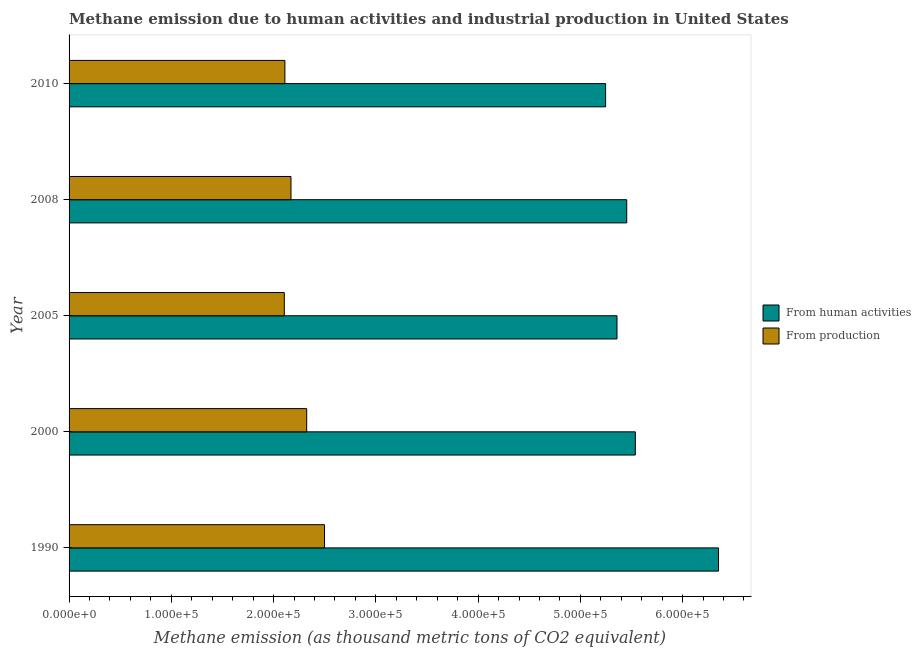How many groups of bars are there?
Offer a terse response. 5. Are the number of bars per tick equal to the number of legend labels?
Provide a succinct answer. Yes. Are the number of bars on each tick of the Y-axis equal?
Provide a succinct answer. Yes. How many bars are there on the 3rd tick from the top?
Make the answer very short. 2. What is the label of the 2nd group of bars from the top?
Keep it short and to the point. 2008. In how many cases, is the number of bars for a given year not equal to the number of legend labels?
Ensure brevity in your answer.  0. What is the amount of emissions generated from industries in 2008?
Your answer should be compact. 2.17e+05. Across all years, what is the maximum amount of emissions from human activities?
Offer a very short reply. 6.35e+05. Across all years, what is the minimum amount of emissions generated from industries?
Provide a succinct answer. 2.10e+05. In which year was the amount of emissions generated from industries maximum?
Provide a succinct answer. 1990. In which year was the amount of emissions from human activities minimum?
Give a very brief answer. 2010. What is the total amount of emissions generated from industries in the graph?
Provide a succinct answer. 1.12e+06. What is the difference between the amount of emissions generated from industries in 2000 and that in 2005?
Keep it short and to the point. 2.19e+04. What is the difference between the amount of emissions generated from industries in 2005 and the amount of emissions from human activities in 2008?
Your response must be concise. -3.35e+05. What is the average amount of emissions generated from industries per year?
Offer a terse response. 2.24e+05. In the year 2000, what is the difference between the amount of emissions generated from industries and amount of emissions from human activities?
Ensure brevity in your answer.  -3.21e+05. In how many years, is the amount of emissions generated from industries greater than 340000 thousand metric tons?
Provide a succinct answer. 0. What is the ratio of the amount of emissions generated from industries in 1990 to that in 2005?
Ensure brevity in your answer.  1.19. Is the amount of emissions generated from industries in 1990 less than that in 2000?
Your answer should be compact. No. What is the difference between the highest and the second highest amount of emissions from human activities?
Offer a very short reply. 8.14e+04. What is the difference between the highest and the lowest amount of emissions generated from industries?
Offer a terse response. 3.93e+04. Is the sum of the amount of emissions generated from industries in 1990 and 2005 greater than the maximum amount of emissions from human activities across all years?
Your answer should be compact. No. What does the 1st bar from the top in 2000 represents?
Offer a terse response. From production. What does the 1st bar from the bottom in 2008 represents?
Your answer should be very brief. From human activities. How many bars are there?
Ensure brevity in your answer.  10. How many years are there in the graph?
Provide a succinct answer. 5. What is the difference between two consecutive major ticks on the X-axis?
Offer a very short reply. 1.00e+05. Are the values on the major ticks of X-axis written in scientific E-notation?
Your response must be concise. Yes. Does the graph contain any zero values?
Provide a short and direct response. No. What is the title of the graph?
Make the answer very short. Methane emission due to human activities and industrial production in United States. Does "Savings" appear as one of the legend labels in the graph?
Your answer should be very brief. No. What is the label or title of the X-axis?
Make the answer very short. Methane emission (as thousand metric tons of CO2 equivalent). What is the label or title of the Y-axis?
Offer a terse response. Year. What is the Methane emission (as thousand metric tons of CO2 equivalent) in From human activities in 1990?
Your response must be concise. 6.35e+05. What is the Methane emission (as thousand metric tons of CO2 equivalent) of From production in 1990?
Offer a very short reply. 2.50e+05. What is the Methane emission (as thousand metric tons of CO2 equivalent) in From human activities in 2000?
Make the answer very short. 5.54e+05. What is the Methane emission (as thousand metric tons of CO2 equivalent) in From production in 2000?
Ensure brevity in your answer.  2.32e+05. What is the Methane emission (as thousand metric tons of CO2 equivalent) in From human activities in 2005?
Make the answer very short. 5.36e+05. What is the Methane emission (as thousand metric tons of CO2 equivalent) of From production in 2005?
Your answer should be very brief. 2.10e+05. What is the Methane emission (as thousand metric tons of CO2 equivalent) of From human activities in 2008?
Your answer should be very brief. 5.45e+05. What is the Methane emission (as thousand metric tons of CO2 equivalent) in From production in 2008?
Offer a terse response. 2.17e+05. What is the Methane emission (as thousand metric tons of CO2 equivalent) in From human activities in 2010?
Offer a terse response. 5.25e+05. What is the Methane emission (as thousand metric tons of CO2 equivalent) in From production in 2010?
Make the answer very short. 2.11e+05. Across all years, what is the maximum Methane emission (as thousand metric tons of CO2 equivalent) in From human activities?
Offer a terse response. 6.35e+05. Across all years, what is the maximum Methane emission (as thousand metric tons of CO2 equivalent) in From production?
Keep it short and to the point. 2.50e+05. Across all years, what is the minimum Methane emission (as thousand metric tons of CO2 equivalent) of From human activities?
Provide a succinct answer. 5.25e+05. Across all years, what is the minimum Methane emission (as thousand metric tons of CO2 equivalent) of From production?
Your answer should be compact. 2.10e+05. What is the total Methane emission (as thousand metric tons of CO2 equivalent) of From human activities in the graph?
Make the answer very short. 2.79e+06. What is the total Methane emission (as thousand metric tons of CO2 equivalent) of From production in the graph?
Provide a succinct answer. 1.12e+06. What is the difference between the Methane emission (as thousand metric tons of CO2 equivalent) in From human activities in 1990 and that in 2000?
Offer a terse response. 8.14e+04. What is the difference between the Methane emission (as thousand metric tons of CO2 equivalent) of From production in 1990 and that in 2000?
Ensure brevity in your answer.  1.74e+04. What is the difference between the Methane emission (as thousand metric tons of CO2 equivalent) in From human activities in 1990 and that in 2005?
Offer a terse response. 9.93e+04. What is the difference between the Methane emission (as thousand metric tons of CO2 equivalent) of From production in 1990 and that in 2005?
Your answer should be compact. 3.93e+04. What is the difference between the Methane emission (as thousand metric tons of CO2 equivalent) of From human activities in 1990 and that in 2008?
Offer a terse response. 8.98e+04. What is the difference between the Methane emission (as thousand metric tons of CO2 equivalent) of From production in 1990 and that in 2008?
Your response must be concise. 3.28e+04. What is the difference between the Methane emission (as thousand metric tons of CO2 equivalent) in From human activities in 1990 and that in 2010?
Offer a terse response. 1.10e+05. What is the difference between the Methane emission (as thousand metric tons of CO2 equivalent) of From production in 1990 and that in 2010?
Your answer should be compact. 3.87e+04. What is the difference between the Methane emission (as thousand metric tons of CO2 equivalent) in From human activities in 2000 and that in 2005?
Keep it short and to the point. 1.79e+04. What is the difference between the Methane emission (as thousand metric tons of CO2 equivalent) of From production in 2000 and that in 2005?
Ensure brevity in your answer.  2.19e+04. What is the difference between the Methane emission (as thousand metric tons of CO2 equivalent) of From human activities in 2000 and that in 2008?
Keep it short and to the point. 8414.7. What is the difference between the Methane emission (as thousand metric tons of CO2 equivalent) in From production in 2000 and that in 2008?
Offer a very short reply. 1.54e+04. What is the difference between the Methane emission (as thousand metric tons of CO2 equivalent) in From human activities in 2000 and that in 2010?
Your answer should be very brief. 2.91e+04. What is the difference between the Methane emission (as thousand metric tons of CO2 equivalent) in From production in 2000 and that in 2010?
Offer a very short reply. 2.13e+04. What is the difference between the Methane emission (as thousand metric tons of CO2 equivalent) in From human activities in 2005 and that in 2008?
Provide a short and direct response. -9510.3. What is the difference between the Methane emission (as thousand metric tons of CO2 equivalent) in From production in 2005 and that in 2008?
Provide a succinct answer. -6538.2. What is the difference between the Methane emission (as thousand metric tons of CO2 equivalent) in From human activities in 2005 and that in 2010?
Your answer should be compact. 1.11e+04. What is the difference between the Methane emission (as thousand metric tons of CO2 equivalent) of From production in 2005 and that in 2010?
Make the answer very short. -598.4. What is the difference between the Methane emission (as thousand metric tons of CO2 equivalent) in From human activities in 2008 and that in 2010?
Keep it short and to the point. 2.06e+04. What is the difference between the Methane emission (as thousand metric tons of CO2 equivalent) in From production in 2008 and that in 2010?
Provide a succinct answer. 5939.8. What is the difference between the Methane emission (as thousand metric tons of CO2 equivalent) in From human activities in 1990 and the Methane emission (as thousand metric tons of CO2 equivalent) in From production in 2000?
Keep it short and to the point. 4.03e+05. What is the difference between the Methane emission (as thousand metric tons of CO2 equivalent) in From human activities in 1990 and the Methane emission (as thousand metric tons of CO2 equivalent) in From production in 2005?
Your response must be concise. 4.25e+05. What is the difference between the Methane emission (as thousand metric tons of CO2 equivalent) in From human activities in 1990 and the Methane emission (as thousand metric tons of CO2 equivalent) in From production in 2008?
Provide a succinct answer. 4.18e+05. What is the difference between the Methane emission (as thousand metric tons of CO2 equivalent) of From human activities in 1990 and the Methane emission (as thousand metric tons of CO2 equivalent) of From production in 2010?
Your answer should be compact. 4.24e+05. What is the difference between the Methane emission (as thousand metric tons of CO2 equivalent) in From human activities in 2000 and the Methane emission (as thousand metric tons of CO2 equivalent) in From production in 2005?
Your answer should be compact. 3.43e+05. What is the difference between the Methane emission (as thousand metric tons of CO2 equivalent) of From human activities in 2000 and the Methane emission (as thousand metric tons of CO2 equivalent) of From production in 2008?
Your response must be concise. 3.37e+05. What is the difference between the Methane emission (as thousand metric tons of CO2 equivalent) of From human activities in 2000 and the Methane emission (as thousand metric tons of CO2 equivalent) of From production in 2010?
Keep it short and to the point. 3.43e+05. What is the difference between the Methane emission (as thousand metric tons of CO2 equivalent) in From human activities in 2005 and the Methane emission (as thousand metric tons of CO2 equivalent) in From production in 2008?
Offer a very short reply. 3.19e+05. What is the difference between the Methane emission (as thousand metric tons of CO2 equivalent) in From human activities in 2005 and the Methane emission (as thousand metric tons of CO2 equivalent) in From production in 2010?
Your answer should be very brief. 3.25e+05. What is the difference between the Methane emission (as thousand metric tons of CO2 equivalent) of From human activities in 2008 and the Methane emission (as thousand metric tons of CO2 equivalent) of From production in 2010?
Make the answer very short. 3.34e+05. What is the average Methane emission (as thousand metric tons of CO2 equivalent) in From human activities per year?
Ensure brevity in your answer.  5.59e+05. What is the average Methane emission (as thousand metric tons of CO2 equivalent) in From production per year?
Keep it short and to the point. 2.24e+05. In the year 1990, what is the difference between the Methane emission (as thousand metric tons of CO2 equivalent) in From human activities and Methane emission (as thousand metric tons of CO2 equivalent) in From production?
Your answer should be very brief. 3.85e+05. In the year 2000, what is the difference between the Methane emission (as thousand metric tons of CO2 equivalent) in From human activities and Methane emission (as thousand metric tons of CO2 equivalent) in From production?
Ensure brevity in your answer.  3.21e+05. In the year 2005, what is the difference between the Methane emission (as thousand metric tons of CO2 equivalent) of From human activities and Methane emission (as thousand metric tons of CO2 equivalent) of From production?
Give a very brief answer. 3.25e+05. In the year 2008, what is the difference between the Methane emission (as thousand metric tons of CO2 equivalent) of From human activities and Methane emission (as thousand metric tons of CO2 equivalent) of From production?
Give a very brief answer. 3.28e+05. In the year 2010, what is the difference between the Methane emission (as thousand metric tons of CO2 equivalent) in From human activities and Methane emission (as thousand metric tons of CO2 equivalent) in From production?
Give a very brief answer. 3.14e+05. What is the ratio of the Methane emission (as thousand metric tons of CO2 equivalent) in From human activities in 1990 to that in 2000?
Offer a terse response. 1.15. What is the ratio of the Methane emission (as thousand metric tons of CO2 equivalent) in From production in 1990 to that in 2000?
Keep it short and to the point. 1.07. What is the ratio of the Methane emission (as thousand metric tons of CO2 equivalent) of From human activities in 1990 to that in 2005?
Your response must be concise. 1.19. What is the ratio of the Methane emission (as thousand metric tons of CO2 equivalent) of From production in 1990 to that in 2005?
Make the answer very short. 1.19. What is the ratio of the Methane emission (as thousand metric tons of CO2 equivalent) in From human activities in 1990 to that in 2008?
Your answer should be very brief. 1.16. What is the ratio of the Methane emission (as thousand metric tons of CO2 equivalent) of From production in 1990 to that in 2008?
Provide a short and direct response. 1.15. What is the ratio of the Methane emission (as thousand metric tons of CO2 equivalent) of From human activities in 1990 to that in 2010?
Provide a short and direct response. 1.21. What is the ratio of the Methane emission (as thousand metric tons of CO2 equivalent) in From production in 1990 to that in 2010?
Provide a succinct answer. 1.18. What is the ratio of the Methane emission (as thousand metric tons of CO2 equivalent) of From human activities in 2000 to that in 2005?
Your answer should be compact. 1.03. What is the ratio of the Methane emission (as thousand metric tons of CO2 equivalent) in From production in 2000 to that in 2005?
Offer a very short reply. 1.1. What is the ratio of the Methane emission (as thousand metric tons of CO2 equivalent) in From human activities in 2000 to that in 2008?
Make the answer very short. 1.02. What is the ratio of the Methane emission (as thousand metric tons of CO2 equivalent) in From production in 2000 to that in 2008?
Provide a succinct answer. 1.07. What is the ratio of the Methane emission (as thousand metric tons of CO2 equivalent) in From human activities in 2000 to that in 2010?
Ensure brevity in your answer.  1.06. What is the ratio of the Methane emission (as thousand metric tons of CO2 equivalent) in From production in 2000 to that in 2010?
Provide a succinct answer. 1.1. What is the ratio of the Methane emission (as thousand metric tons of CO2 equivalent) in From human activities in 2005 to that in 2008?
Provide a succinct answer. 0.98. What is the ratio of the Methane emission (as thousand metric tons of CO2 equivalent) in From production in 2005 to that in 2008?
Your answer should be very brief. 0.97. What is the ratio of the Methane emission (as thousand metric tons of CO2 equivalent) of From human activities in 2005 to that in 2010?
Your answer should be very brief. 1.02. What is the ratio of the Methane emission (as thousand metric tons of CO2 equivalent) in From production in 2005 to that in 2010?
Your answer should be compact. 1. What is the ratio of the Methane emission (as thousand metric tons of CO2 equivalent) of From human activities in 2008 to that in 2010?
Offer a terse response. 1.04. What is the ratio of the Methane emission (as thousand metric tons of CO2 equivalent) of From production in 2008 to that in 2010?
Your answer should be very brief. 1.03. What is the difference between the highest and the second highest Methane emission (as thousand metric tons of CO2 equivalent) of From human activities?
Offer a terse response. 8.14e+04. What is the difference between the highest and the second highest Methane emission (as thousand metric tons of CO2 equivalent) in From production?
Offer a very short reply. 1.74e+04. What is the difference between the highest and the lowest Methane emission (as thousand metric tons of CO2 equivalent) in From human activities?
Offer a very short reply. 1.10e+05. What is the difference between the highest and the lowest Methane emission (as thousand metric tons of CO2 equivalent) of From production?
Your response must be concise. 3.93e+04. 